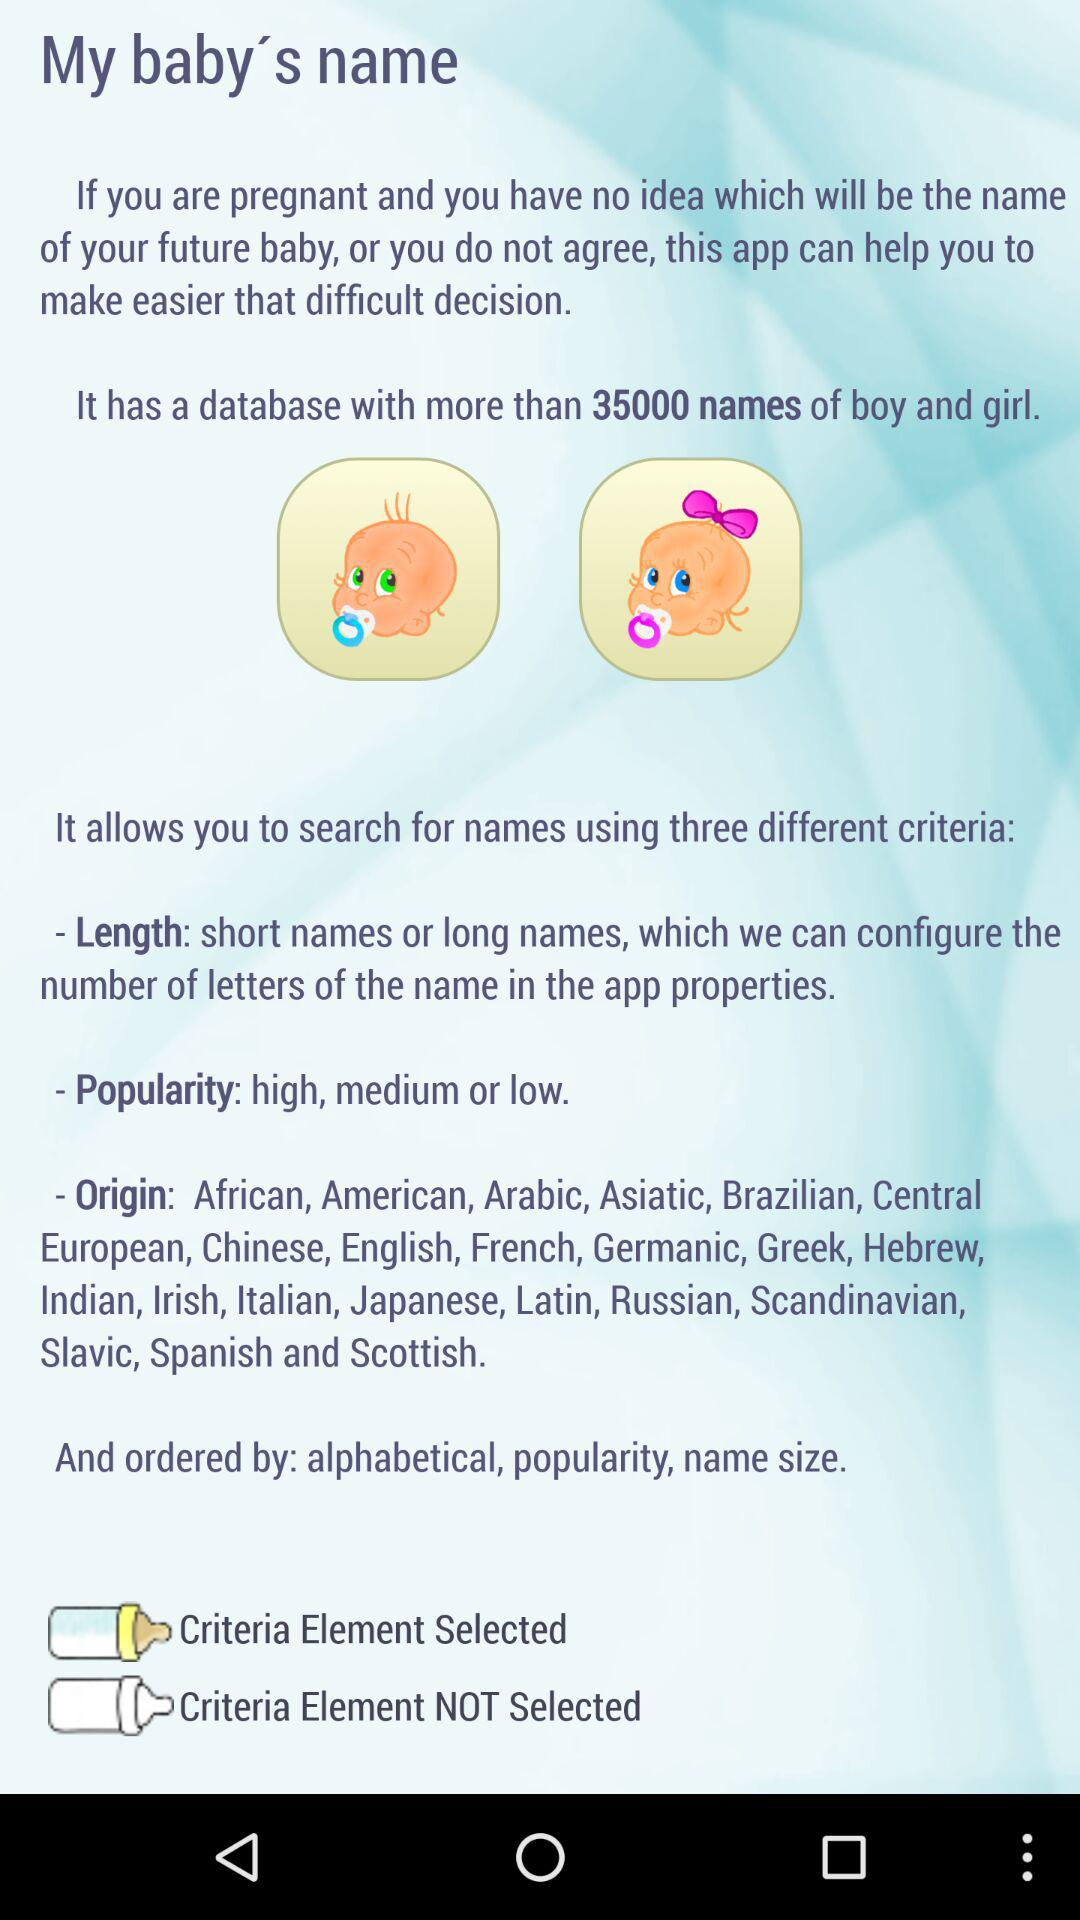How many total names are there in the database? There are more than 35,000 names in the database. 